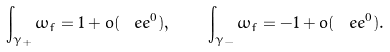Convert formula to latex. <formula><loc_0><loc_0><loc_500><loc_500>\int _ { \gamma _ { + } } { \omega _ { f } } = 1 + o ( \ e e ^ { 0 } ) , \quad \int _ { \gamma _ { - } } { \omega _ { f } } = - 1 + o ( \ e e ^ { 0 } ) .</formula> 